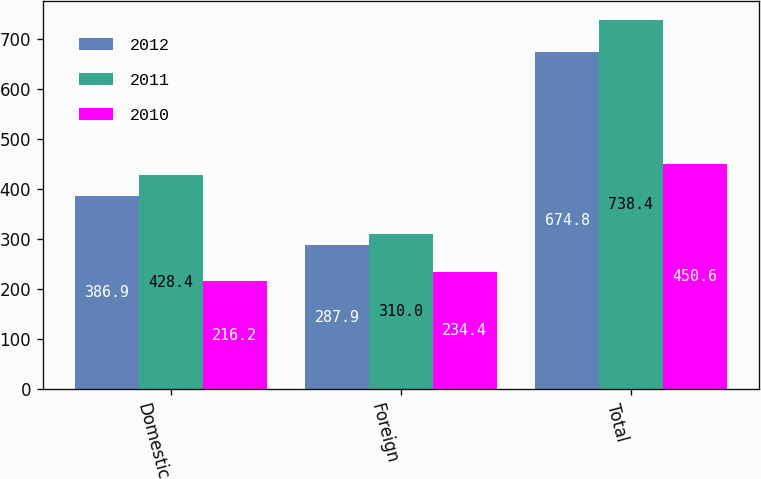Convert chart to OTSL. <chart><loc_0><loc_0><loc_500><loc_500><stacked_bar_chart><ecel><fcel>Domestic<fcel>Foreign<fcel>Total<nl><fcel>2012<fcel>386.9<fcel>287.9<fcel>674.8<nl><fcel>2011<fcel>428.4<fcel>310<fcel>738.4<nl><fcel>2010<fcel>216.2<fcel>234.4<fcel>450.6<nl></chart> 